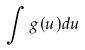Convert formula to latex. <formula><loc_0><loc_0><loc_500><loc_500>\int g ( u ) d u</formula> 